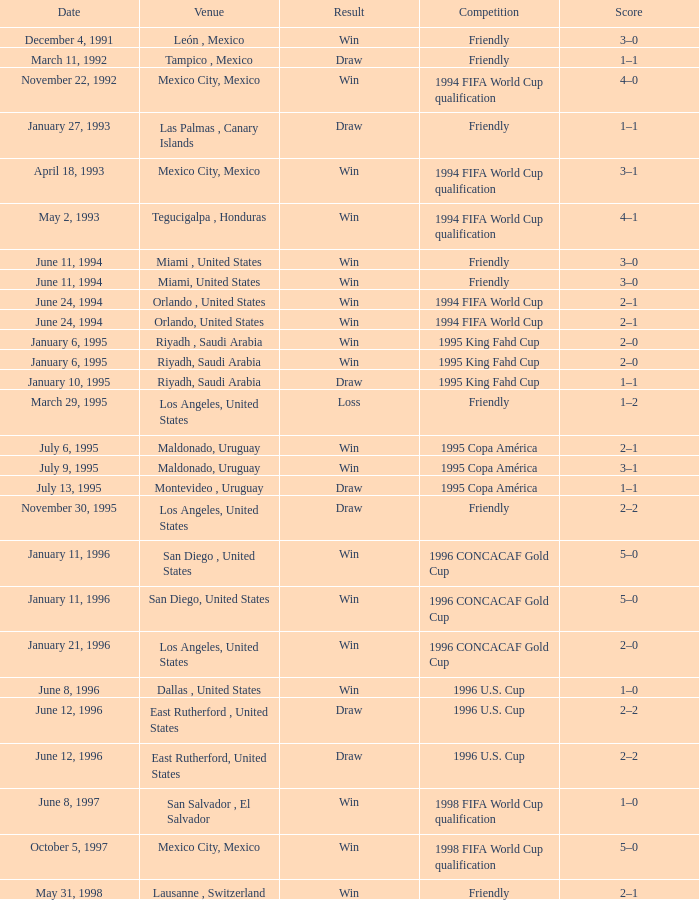What is Venue, when Date is "January 6, 1995"? Riyadh , Saudi Arabia, Riyadh, Saudi Arabia. 